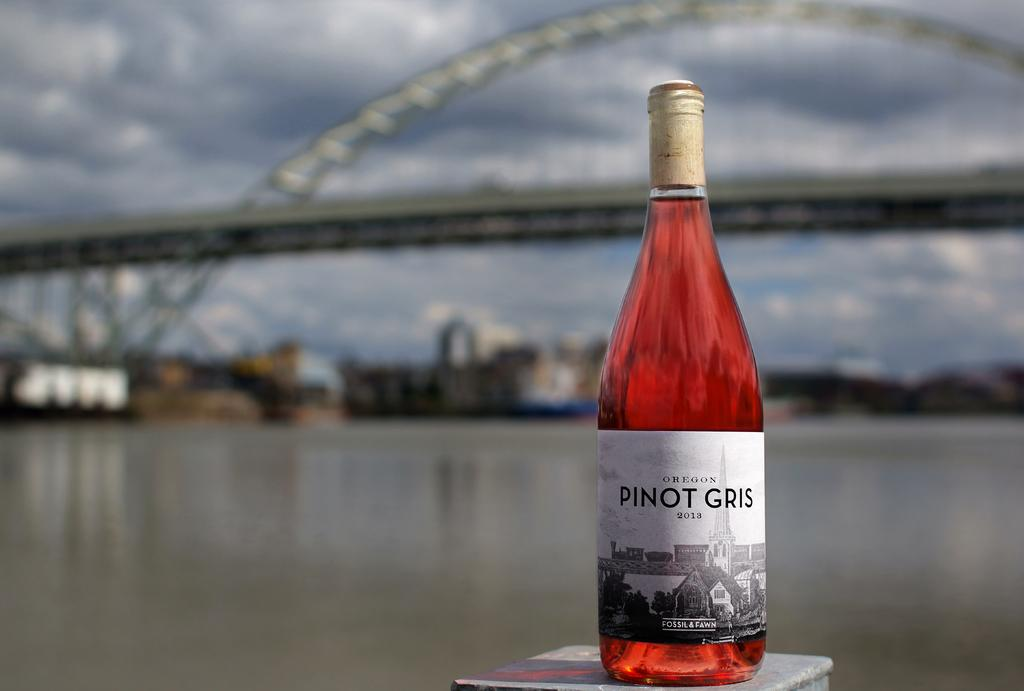<image>
Write a terse but informative summary of the picture. A single bottle of Pinot Gris with an out of focused waterway behind it. 